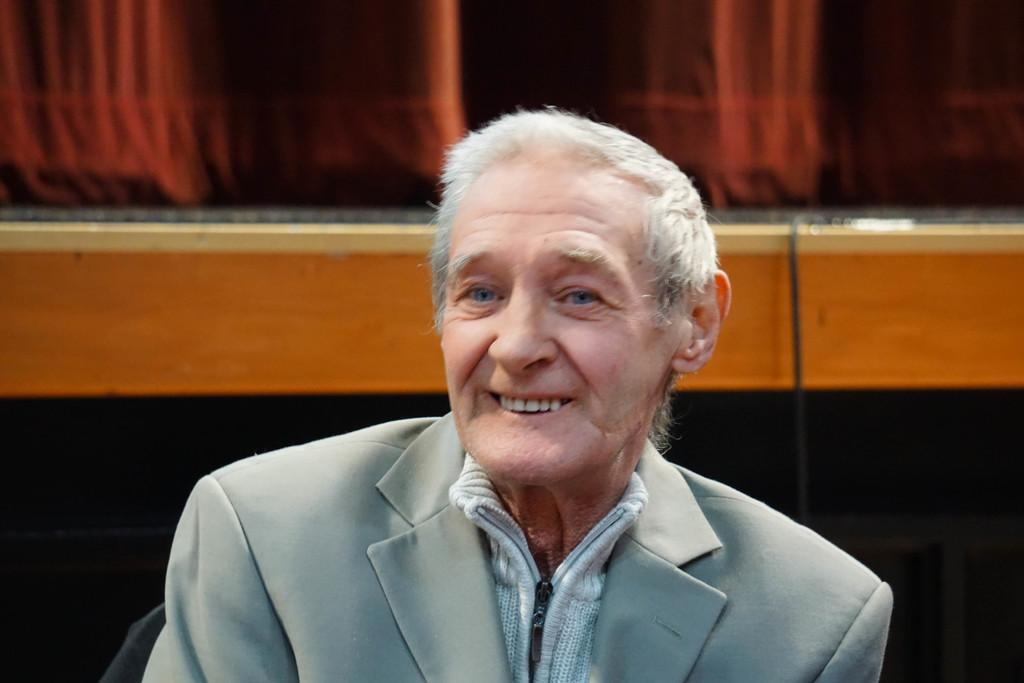What is the main subject of the image? There is a person sitting in the center of the image. What is the person's facial expression? The person is smiling. What can be seen in the background of the image? There is a board and a curtain in the background of the image. What type of sleet can be seen falling in the image? There is no sleet present in the image. What is the person using to plough the field in the image? There is no plough or field present in the image. 